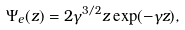<formula> <loc_0><loc_0><loc_500><loc_500>\Psi _ { e } ( z ) = 2 \gamma ^ { 3 / 2 } z \exp ( - \gamma z ) ,</formula> 